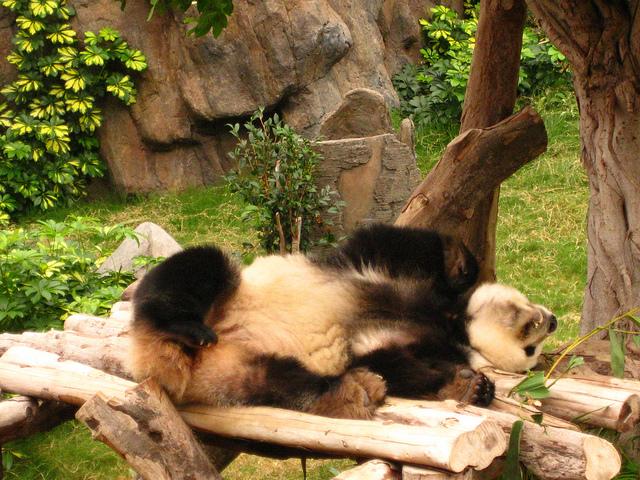Is this a male bear?
Short answer required. No. Is this animal resting?
Write a very short answer. Yes. What are the two main colors of the animal?
Answer briefly. Black and white. 